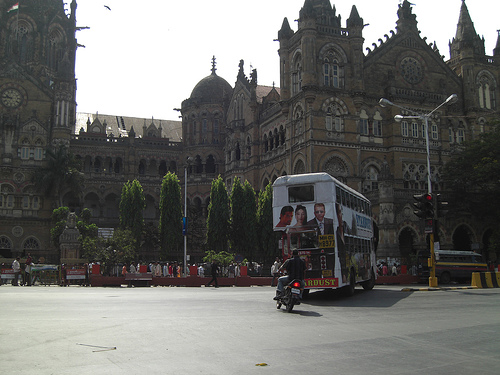<image>
Is there a bike behind the bus? Yes. From this viewpoint, the bike is positioned behind the bus, with the bus partially or fully occluding the bike. Is the van in front of the bike? Yes. The van is positioned in front of the bike, appearing closer to the camera viewpoint. 